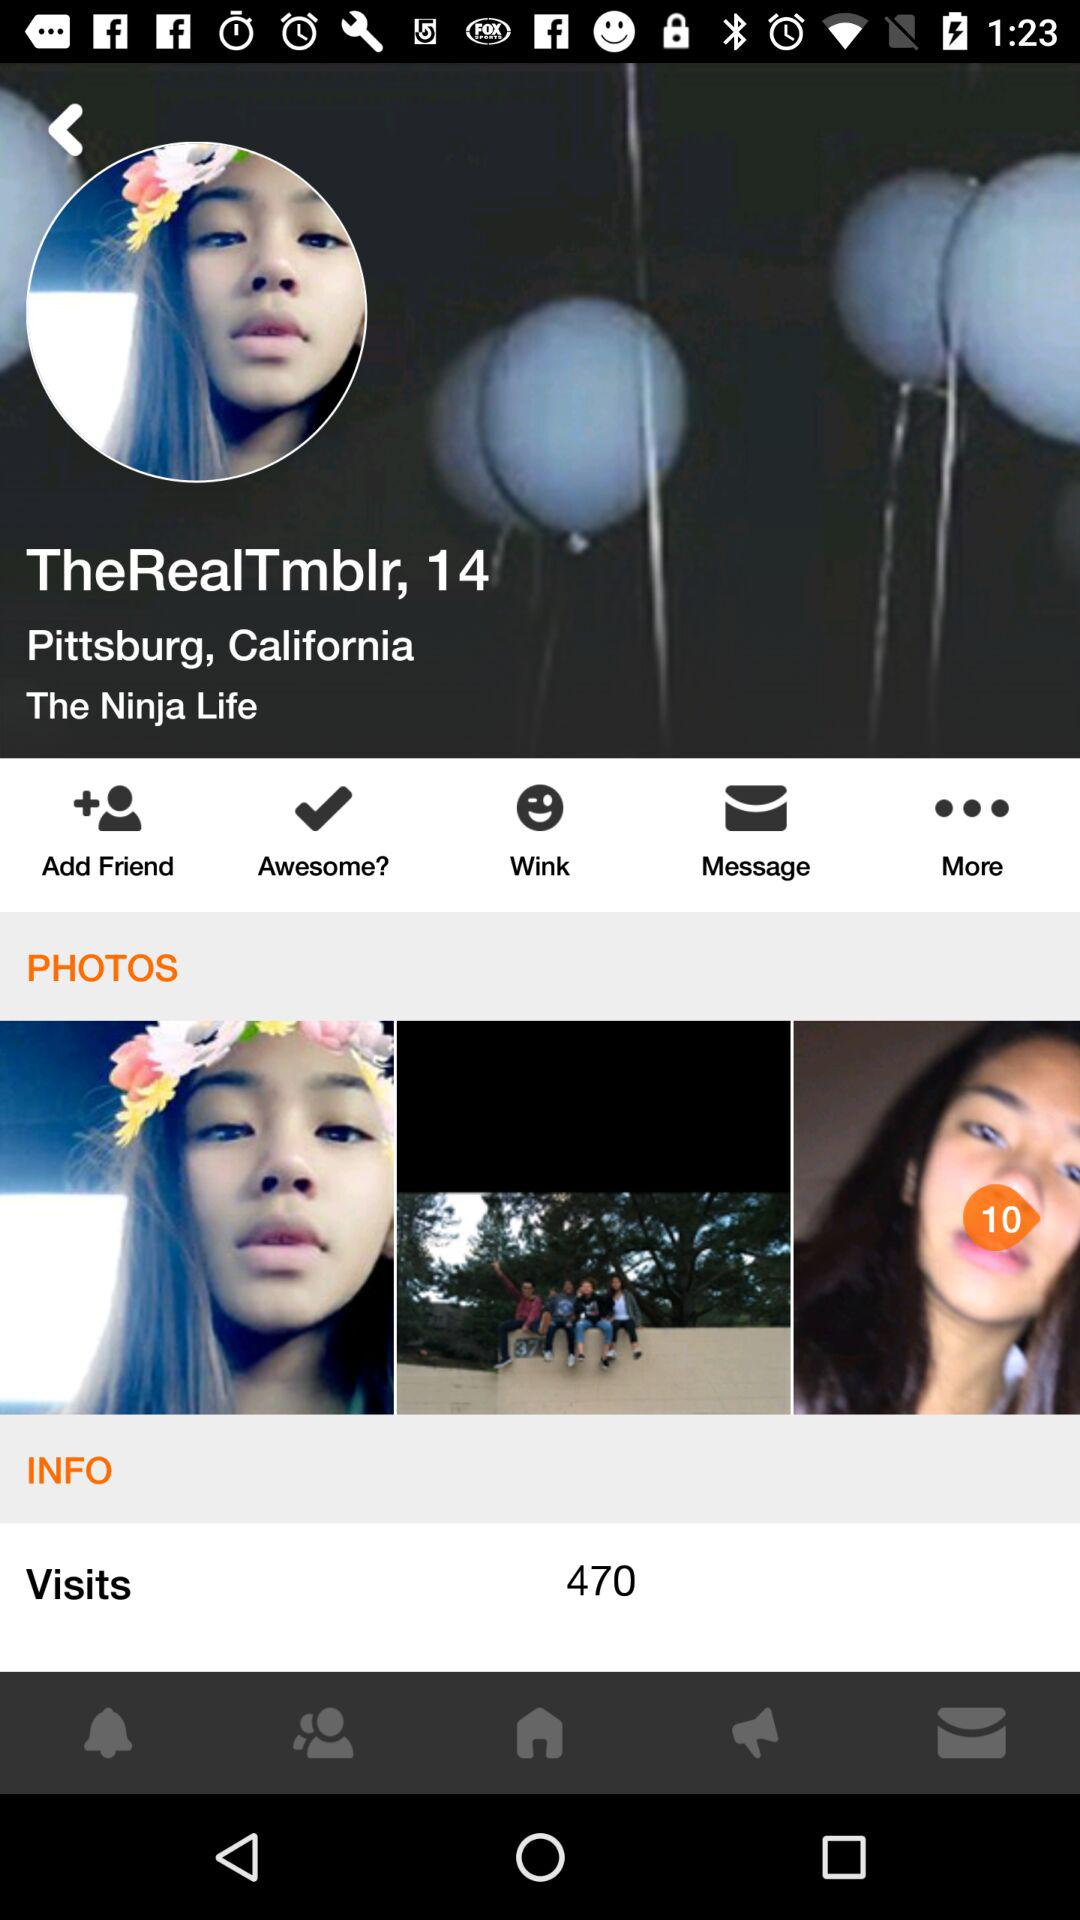What is the username? The username is "TheRealTmblr". 